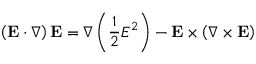<formula> <loc_0><loc_0><loc_500><loc_500>\left ( E \cdot \nabla \right ) E = \nabla \left ( { \frac { 1 } { 2 } } E ^ { 2 } \right ) - E \times \left ( \nabla \times E \right )</formula> 